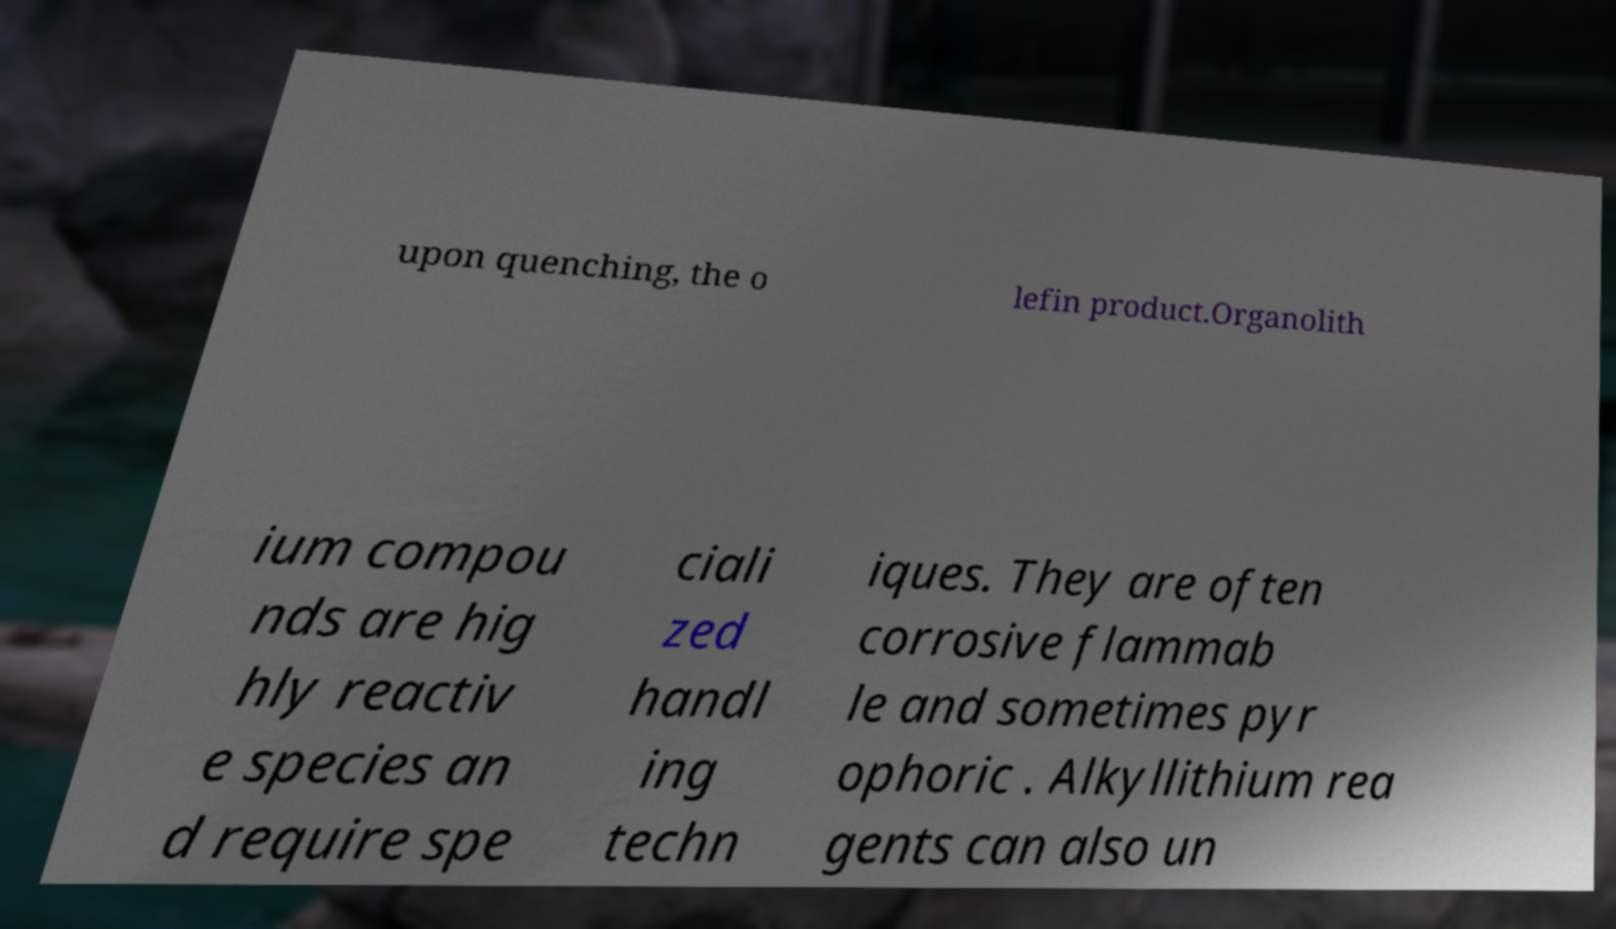Please identify and transcribe the text found in this image. upon quenching, the o lefin product.Organolith ium compou nds are hig hly reactiv e species an d require spe ciali zed handl ing techn iques. They are often corrosive flammab le and sometimes pyr ophoric . Alkyllithium rea gents can also un 